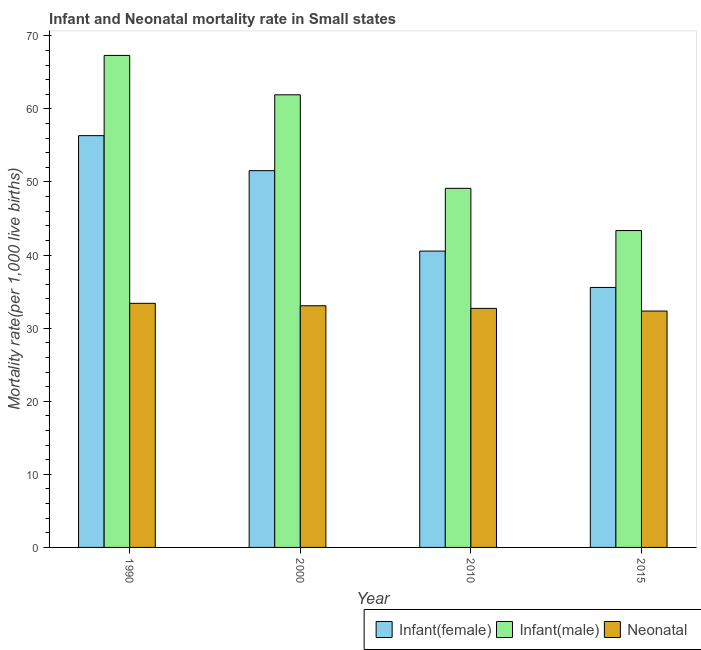How many different coloured bars are there?
Provide a short and direct response. 3. What is the label of the 4th group of bars from the left?
Your answer should be very brief. 2015. In how many cases, is the number of bars for a given year not equal to the number of legend labels?
Make the answer very short. 0. What is the infant mortality rate(male) in 1990?
Give a very brief answer. 67.31. Across all years, what is the maximum infant mortality rate(female)?
Keep it short and to the point. 56.34. Across all years, what is the minimum infant mortality rate(female)?
Ensure brevity in your answer.  35.57. In which year was the neonatal mortality rate minimum?
Give a very brief answer. 2015. What is the total neonatal mortality rate in the graph?
Offer a very short reply. 131.51. What is the difference between the infant mortality rate(male) in 2000 and that in 2015?
Give a very brief answer. 18.57. What is the difference between the infant mortality rate(female) in 2000 and the neonatal mortality rate in 1990?
Ensure brevity in your answer.  -4.79. What is the average infant mortality rate(female) per year?
Your response must be concise. 46. In the year 2000, what is the difference between the neonatal mortality rate and infant mortality rate(male)?
Provide a short and direct response. 0. In how many years, is the neonatal mortality rate greater than 62?
Your answer should be very brief. 0. What is the ratio of the infant mortality rate(female) in 2000 to that in 2010?
Offer a very short reply. 1.27. Is the difference between the infant mortality rate(female) in 1990 and 2015 greater than the difference between the neonatal mortality rate in 1990 and 2015?
Your response must be concise. No. What is the difference between the highest and the second highest neonatal mortality rate?
Keep it short and to the point. 0.33. What is the difference between the highest and the lowest neonatal mortality rate?
Provide a succinct answer. 1.05. Is the sum of the infant mortality rate(female) in 1990 and 2010 greater than the maximum infant mortality rate(male) across all years?
Your answer should be very brief. Yes. What does the 2nd bar from the left in 2000 represents?
Ensure brevity in your answer.  Infant(male). What does the 1st bar from the right in 2010 represents?
Your answer should be compact. Neonatal . Is it the case that in every year, the sum of the infant mortality rate(female) and infant mortality rate(male) is greater than the neonatal mortality rate?
Your response must be concise. Yes. How many years are there in the graph?
Your response must be concise. 4. What is the difference between two consecutive major ticks on the Y-axis?
Give a very brief answer. 10. Are the values on the major ticks of Y-axis written in scientific E-notation?
Keep it short and to the point. No. Does the graph contain any zero values?
Provide a short and direct response. No. Where does the legend appear in the graph?
Provide a succinct answer. Bottom right. How are the legend labels stacked?
Ensure brevity in your answer.  Horizontal. What is the title of the graph?
Your answer should be very brief. Infant and Neonatal mortality rate in Small states. What is the label or title of the X-axis?
Your answer should be compact. Year. What is the label or title of the Y-axis?
Ensure brevity in your answer.  Mortality rate(per 1,0 live births). What is the Mortality rate(per 1,000 live births) of Infant(female) in 1990?
Your answer should be compact. 56.34. What is the Mortality rate(per 1,000 live births) in Infant(male) in 1990?
Your answer should be compact. 67.31. What is the Mortality rate(per 1,000 live births) in Neonatal  in 1990?
Offer a very short reply. 33.4. What is the Mortality rate(per 1,000 live births) in Infant(female) in 2000?
Your response must be concise. 51.55. What is the Mortality rate(per 1,000 live births) of Infant(male) in 2000?
Give a very brief answer. 61.93. What is the Mortality rate(per 1,000 live births) in Neonatal  in 2000?
Make the answer very short. 33.06. What is the Mortality rate(per 1,000 live births) of Infant(female) in 2010?
Offer a terse response. 40.54. What is the Mortality rate(per 1,000 live births) of Infant(male) in 2010?
Provide a succinct answer. 49.13. What is the Mortality rate(per 1,000 live births) in Neonatal  in 2010?
Ensure brevity in your answer.  32.7. What is the Mortality rate(per 1,000 live births) in Infant(female) in 2015?
Provide a succinct answer. 35.57. What is the Mortality rate(per 1,000 live births) in Infant(male) in 2015?
Offer a terse response. 43.35. What is the Mortality rate(per 1,000 live births) in Neonatal  in 2015?
Your answer should be very brief. 32.34. Across all years, what is the maximum Mortality rate(per 1,000 live births) of Infant(female)?
Keep it short and to the point. 56.34. Across all years, what is the maximum Mortality rate(per 1,000 live births) of Infant(male)?
Your response must be concise. 67.31. Across all years, what is the maximum Mortality rate(per 1,000 live births) of Neonatal ?
Give a very brief answer. 33.4. Across all years, what is the minimum Mortality rate(per 1,000 live births) in Infant(female)?
Make the answer very short. 35.57. Across all years, what is the minimum Mortality rate(per 1,000 live births) in Infant(male)?
Offer a very short reply. 43.35. Across all years, what is the minimum Mortality rate(per 1,000 live births) of Neonatal ?
Offer a very short reply. 32.34. What is the total Mortality rate(per 1,000 live births) in Infant(female) in the graph?
Your answer should be compact. 184. What is the total Mortality rate(per 1,000 live births) in Infant(male) in the graph?
Offer a very short reply. 221.72. What is the total Mortality rate(per 1,000 live births) in Neonatal  in the graph?
Your answer should be very brief. 131.51. What is the difference between the Mortality rate(per 1,000 live births) in Infant(female) in 1990 and that in 2000?
Give a very brief answer. 4.79. What is the difference between the Mortality rate(per 1,000 live births) in Infant(male) in 1990 and that in 2000?
Provide a short and direct response. 5.39. What is the difference between the Mortality rate(per 1,000 live births) in Neonatal  in 1990 and that in 2000?
Your answer should be compact. 0.33. What is the difference between the Mortality rate(per 1,000 live births) in Infant(female) in 1990 and that in 2010?
Your answer should be compact. 15.8. What is the difference between the Mortality rate(per 1,000 live births) of Infant(male) in 1990 and that in 2010?
Your response must be concise. 18.19. What is the difference between the Mortality rate(per 1,000 live births) of Neonatal  in 1990 and that in 2010?
Ensure brevity in your answer.  0.69. What is the difference between the Mortality rate(per 1,000 live births) in Infant(female) in 1990 and that in 2015?
Your answer should be very brief. 20.77. What is the difference between the Mortality rate(per 1,000 live births) in Infant(male) in 1990 and that in 2015?
Provide a short and direct response. 23.96. What is the difference between the Mortality rate(per 1,000 live births) in Neonatal  in 1990 and that in 2015?
Make the answer very short. 1.05. What is the difference between the Mortality rate(per 1,000 live births) of Infant(female) in 2000 and that in 2010?
Ensure brevity in your answer.  11.01. What is the difference between the Mortality rate(per 1,000 live births) of Infant(male) in 2000 and that in 2010?
Make the answer very short. 12.8. What is the difference between the Mortality rate(per 1,000 live births) in Neonatal  in 2000 and that in 2010?
Make the answer very short. 0.36. What is the difference between the Mortality rate(per 1,000 live births) of Infant(female) in 2000 and that in 2015?
Give a very brief answer. 15.98. What is the difference between the Mortality rate(per 1,000 live births) of Infant(male) in 2000 and that in 2015?
Give a very brief answer. 18.57. What is the difference between the Mortality rate(per 1,000 live births) of Neonatal  in 2000 and that in 2015?
Your answer should be compact. 0.72. What is the difference between the Mortality rate(per 1,000 live births) in Infant(female) in 2010 and that in 2015?
Your answer should be very brief. 4.97. What is the difference between the Mortality rate(per 1,000 live births) in Infant(male) in 2010 and that in 2015?
Provide a succinct answer. 5.77. What is the difference between the Mortality rate(per 1,000 live births) in Neonatal  in 2010 and that in 2015?
Give a very brief answer. 0.36. What is the difference between the Mortality rate(per 1,000 live births) in Infant(female) in 1990 and the Mortality rate(per 1,000 live births) in Infant(male) in 2000?
Ensure brevity in your answer.  -5.59. What is the difference between the Mortality rate(per 1,000 live births) of Infant(female) in 1990 and the Mortality rate(per 1,000 live births) of Neonatal  in 2000?
Keep it short and to the point. 23.27. What is the difference between the Mortality rate(per 1,000 live births) in Infant(male) in 1990 and the Mortality rate(per 1,000 live births) in Neonatal  in 2000?
Your answer should be very brief. 34.25. What is the difference between the Mortality rate(per 1,000 live births) in Infant(female) in 1990 and the Mortality rate(per 1,000 live births) in Infant(male) in 2010?
Your answer should be compact. 7.21. What is the difference between the Mortality rate(per 1,000 live births) of Infant(female) in 1990 and the Mortality rate(per 1,000 live births) of Neonatal  in 2010?
Your answer should be very brief. 23.63. What is the difference between the Mortality rate(per 1,000 live births) of Infant(male) in 1990 and the Mortality rate(per 1,000 live births) of Neonatal  in 2010?
Make the answer very short. 34.61. What is the difference between the Mortality rate(per 1,000 live births) of Infant(female) in 1990 and the Mortality rate(per 1,000 live births) of Infant(male) in 2015?
Your answer should be compact. 12.99. What is the difference between the Mortality rate(per 1,000 live births) in Infant(female) in 1990 and the Mortality rate(per 1,000 live births) in Neonatal  in 2015?
Provide a succinct answer. 24. What is the difference between the Mortality rate(per 1,000 live births) of Infant(male) in 1990 and the Mortality rate(per 1,000 live births) of Neonatal  in 2015?
Provide a short and direct response. 34.97. What is the difference between the Mortality rate(per 1,000 live births) of Infant(female) in 2000 and the Mortality rate(per 1,000 live births) of Infant(male) in 2010?
Offer a very short reply. 2.42. What is the difference between the Mortality rate(per 1,000 live births) of Infant(female) in 2000 and the Mortality rate(per 1,000 live births) of Neonatal  in 2010?
Make the answer very short. 18.84. What is the difference between the Mortality rate(per 1,000 live births) of Infant(male) in 2000 and the Mortality rate(per 1,000 live births) of Neonatal  in 2010?
Offer a terse response. 29.22. What is the difference between the Mortality rate(per 1,000 live births) in Infant(female) in 2000 and the Mortality rate(per 1,000 live births) in Infant(male) in 2015?
Your answer should be very brief. 8.19. What is the difference between the Mortality rate(per 1,000 live births) in Infant(female) in 2000 and the Mortality rate(per 1,000 live births) in Neonatal  in 2015?
Give a very brief answer. 19.2. What is the difference between the Mortality rate(per 1,000 live births) in Infant(male) in 2000 and the Mortality rate(per 1,000 live births) in Neonatal  in 2015?
Your response must be concise. 29.58. What is the difference between the Mortality rate(per 1,000 live births) of Infant(female) in 2010 and the Mortality rate(per 1,000 live births) of Infant(male) in 2015?
Your response must be concise. -2.81. What is the difference between the Mortality rate(per 1,000 live births) in Infant(female) in 2010 and the Mortality rate(per 1,000 live births) in Neonatal  in 2015?
Provide a succinct answer. 8.2. What is the difference between the Mortality rate(per 1,000 live births) of Infant(male) in 2010 and the Mortality rate(per 1,000 live births) of Neonatal  in 2015?
Your answer should be compact. 16.78. What is the average Mortality rate(per 1,000 live births) of Infant(female) per year?
Your response must be concise. 46. What is the average Mortality rate(per 1,000 live births) in Infant(male) per year?
Offer a very short reply. 55.43. What is the average Mortality rate(per 1,000 live births) in Neonatal  per year?
Offer a terse response. 32.88. In the year 1990, what is the difference between the Mortality rate(per 1,000 live births) in Infant(female) and Mortality rate(per 1,000 live births) in Infant(male)?
Provide a short and direct response. -10.98. In the year 1990, what is the difference between the Mortality rate(per 1,000 live births) in Infant(female) and Mortality rate(per 1,000 live births) in Neonatal ?
Ensure brevity in your answer.  22.94. In the year 1990, what is the difference between the Mortality rate(per 1,000 live births) in Infant(male) and Mortality rate(per 1,000 live births) in Neonatal ?
Your answer should be compact. 33.92. In the year 2000, what is the difference between the Mortality rate(per 1,000 live births) in Infant(female) and Mortality rate(per 1,000 live births) in Infant(male)?
Make the answer very short. -10.38. In the year 2000, what is the difference between the Mortality rate(per 1,000 live births) in Infant(female) and Mortality rate(per 1,000 live births) in Neonatal ?
Ensure brevity in your answer.  18.48. In the year 2000, what is the difference between the Mortality rate(per 1,000 live births) of Infant(male) and Mortality rate(per 1,000 live births) of Neonatal ?
Keep it short and to the point. 28.86. In the year 2010, what is the difference between the Mortality rate(per 1,000 live births) of Infant(female) and Mortality rate(per 1,000 live births) of Infant(male)?
Keep it short and to the point. -8.59. In the year 2010, what is the difference between the Mortality rate(per 1,000 live births) of Infant(female) and Mortality rate(per 1,000 live births) of Neonatal ?
Provide a succinct answer. 7.84. In the year 2010, what is the difference between the Mortality rate(per 1,000 live births) of Infant(male) and Mortality rate(per 1,000 live births) of Neonatal ?
Your response must be concise. 16.42. In the year 2015, what is the difference between the Mortality rate(per 1,000 live births) in Infant(female) and Mortality rate(per 1,000 live births) in Infant(male)?
Give a very brief answer. -7.78. In the year 2015, what is the difference between the Mortality rate(per 1,000 live births) of Infant(female) and Mortality rate(per 1,000 live births) of Neonatal ?
Offer a very short reply. 3.23. In the year 2015, what is the difference between the Mortality rate(per 1,000 live births) in Infant(male) and Mortality rate(per 1,000 live births) in Neonatal ?
Make the answer very short. 11.01. What is the ratio of the Mortality rate(per 1,000 live births) in Infant(female) in 1990 to that in 2000?
Make the answer very short. 1.09. What is the ratio of the Mortality rate(per 1,000 live births) of Infant(male) in 1990 to that in 2000?
Offer a terse response. 1.09. What is the ratio of the Mortality rate(per 1,000 live births) in Neonatal  in 1990 to that in 2000?
Your answer should be compact. 1.01. What is the ratio of the Mortality rate(per 1,000 live births) of Infant(female) in 1990 to that in 2010?
Keep it short and to the point. 1.39. What is the ratio of the Mortality rate(per 1,000 live births) in Infant(male) in 1990 to that in 2010?
Your answer should be very brief. 1.37. What is the ratio of the Mortality rate(per 1,000 live births) in Neonatal  in 1990 to that in 2010?
Make the answer very short. 1.02. What is the ratio of the Mortality rate(per 1,000 live births) of Infant(female) in 1990 to that in 2015?
Your response must be concise. 1.58. What is the ratio of the Mortality rate(per 1,000 live births) in Infant(male) in 1990 to that in 2015?
Keep it short and to the point. 1.55. What is the ratio of the Mortality rate(per 1,000 live births) of Neonatal  in 1990 to that in 2015?
Offer a terse response. 1.03. What is the ratio of the Mortality rate(per 1,000 live births) of Infant(female) in 2000 to that in 2010?
Offer a terse response. 1.27. What is the ratio of the Mortality rate(per 1,000 live births) of Infant(male) in 2000 to that in 2010?
Give a very brief answer. 1.26. What is the ratio of the Mortality rate(per 1,000 live births) of Neonatal  in 2000 to that in 2010?
Provide a short and direct response. 1.01. What is the ratio of the Mortality rate(per 1,000 live births) in Infant(female) in 2000 to that in 2015?
Offer a terse response. 1.45. What is the ratio of the Mortality rate(per 1,000 live births) of Infant(male) in 2000 to that in 2015?
Make the answer very short. 1.43. What is the ratio of the Mortality rate(per 1,000 live births) of Neonatal  in 2000 to that in 2015?
Make the answer very short. 1.02. What is the ratio of the Mortality rate(per 1,000 live births) of Infant(female) in 2010 to that in 2015?
Provide a succinct answer. 1.14. What is the ratio of the Mortality rate(per 1,000 live births) in Infant(male) in 2010 to that in 2015?
Provide a succinct answer. 1.13. What is the ratio of the Mortality rate(per 1,000 live births) in Neonatal  in 2010 to that in 2015?
Provide a short and direct response. 1.01. What is the difference between the highest and the second highest Mortality rate(per 1,000 live births) of Infant(female)?
Your answer should be very brief. 4.79. What is the difference between the highest and the second highest Mortality rate(per 1,000 live births) in Infant(male)?
Make the answer very short. 5.39. What is the difference between the highest and the second highest Mortality rate(per 1,000 live births) in Neonatal ?
Ensure brevity in your answer.  0.33. What is the difference between the highest and the lowest Mortality rate(per 1,000 live births) of Infant(female)?
Your response must be concise. 20.77. What is the difference between the highest and the lowest Mortality rate(per 1,000 live births) in Infant(male)?
Ensure brevity in your answer.  23.96. What is the difference between the highest and the lowest Mortality rate(per 1,000 live births) in Neonatal ?
Your answer should be very brief. 1.05. 